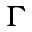Convert formula to latex. <formula><loc_0><loc_0><loc_500><loc_500>\Gamma</formula> 